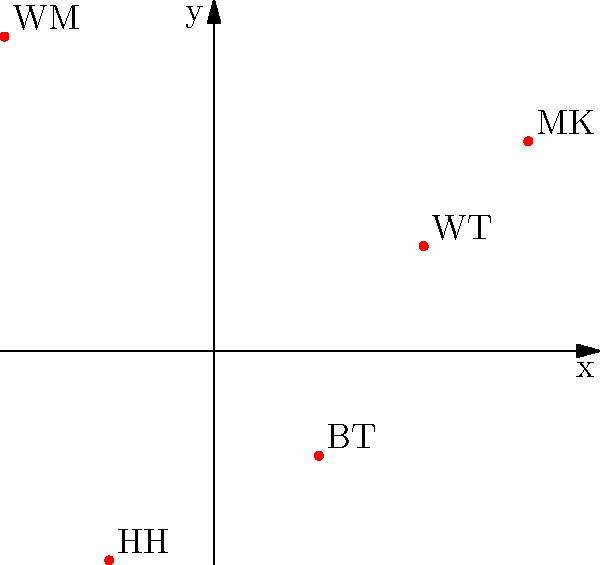The graph shows the locations of five major Kentucky bourbon distilleries on a coordinate plane. WM represents Woodford Reserve, BT is Buffalo Trace, MK is Maker's Mark, HH is Heaven Hill, and WT is Wild Turkey. Which distillery is located at the point $(3, 2)$? To solve this problem, we need to examine the coordinates of each distillery on the graph:

1. WM (Woodford Reserve): $(-2, 3)$
2. BT (Buffalo Trace): $(1, -1)$
3. MK (Maker's Mark): $(3, 2)$
4. HH (Heaven Hill): $(-1, -2)$
5. WT (Wild Turkey): $(2, 1)$

We are looking for the distillery located at the point $(3, 2)$. Comparing this to the coordinates of each distillery, we can see that MK (Maker's Mark) is at $(3, 2)$.
Answer: Maker's Mark 